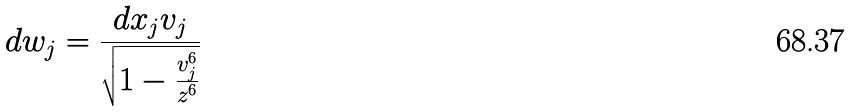<formula> <loc_0><loc_0><loc_500><loc_500>d w _ { j } = \frac { d x _ { j } v _ { j } } { \sqrt { 1 - \frac { v _ { j } ^ { 6 } } { z ^ { 6 } } } }</formula> 